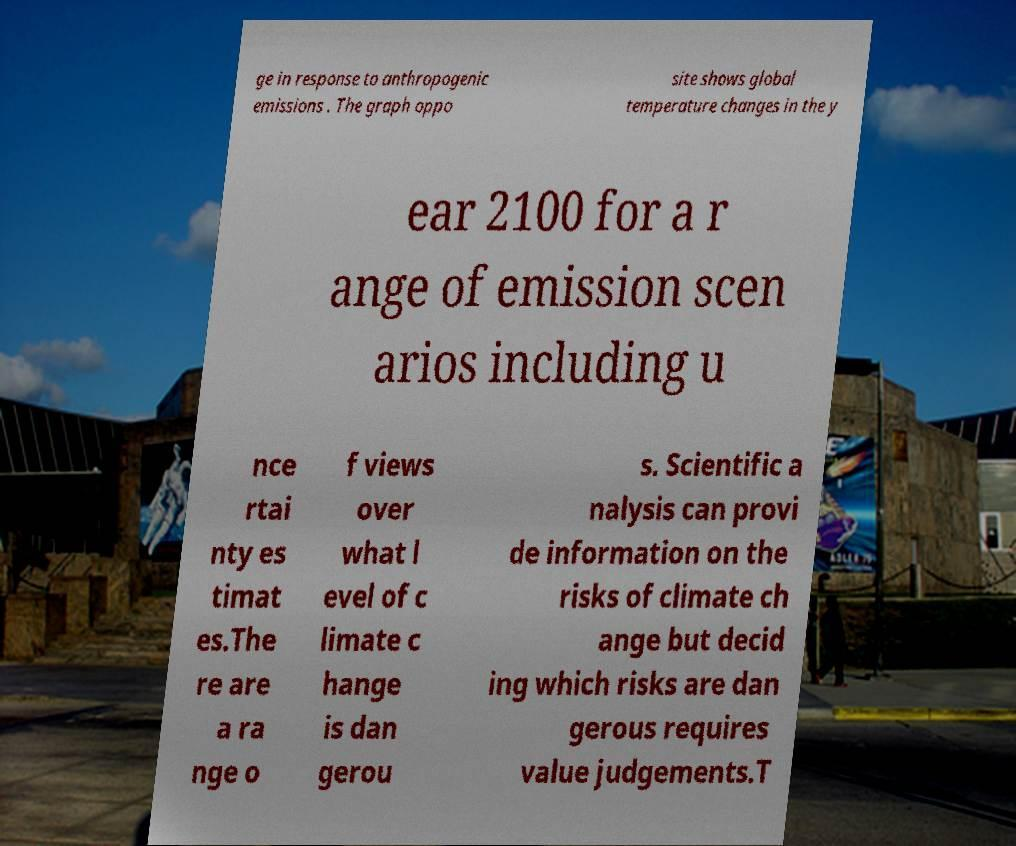Could you extract and type out the text from this image? ge in response to anthropogenic emissions . The graph oppo site shows global temperature changes in the y ear 2100 for a r ange of emission scen arios including u nce rtai nty es timat es.The re are a ra nge o f views over what l evel of c limate c hange is dan gerou s. Scientific a nalysis can provi de information on the risks of climate ch ange but decid ing which risks are dan gerous requires value judgements.T 